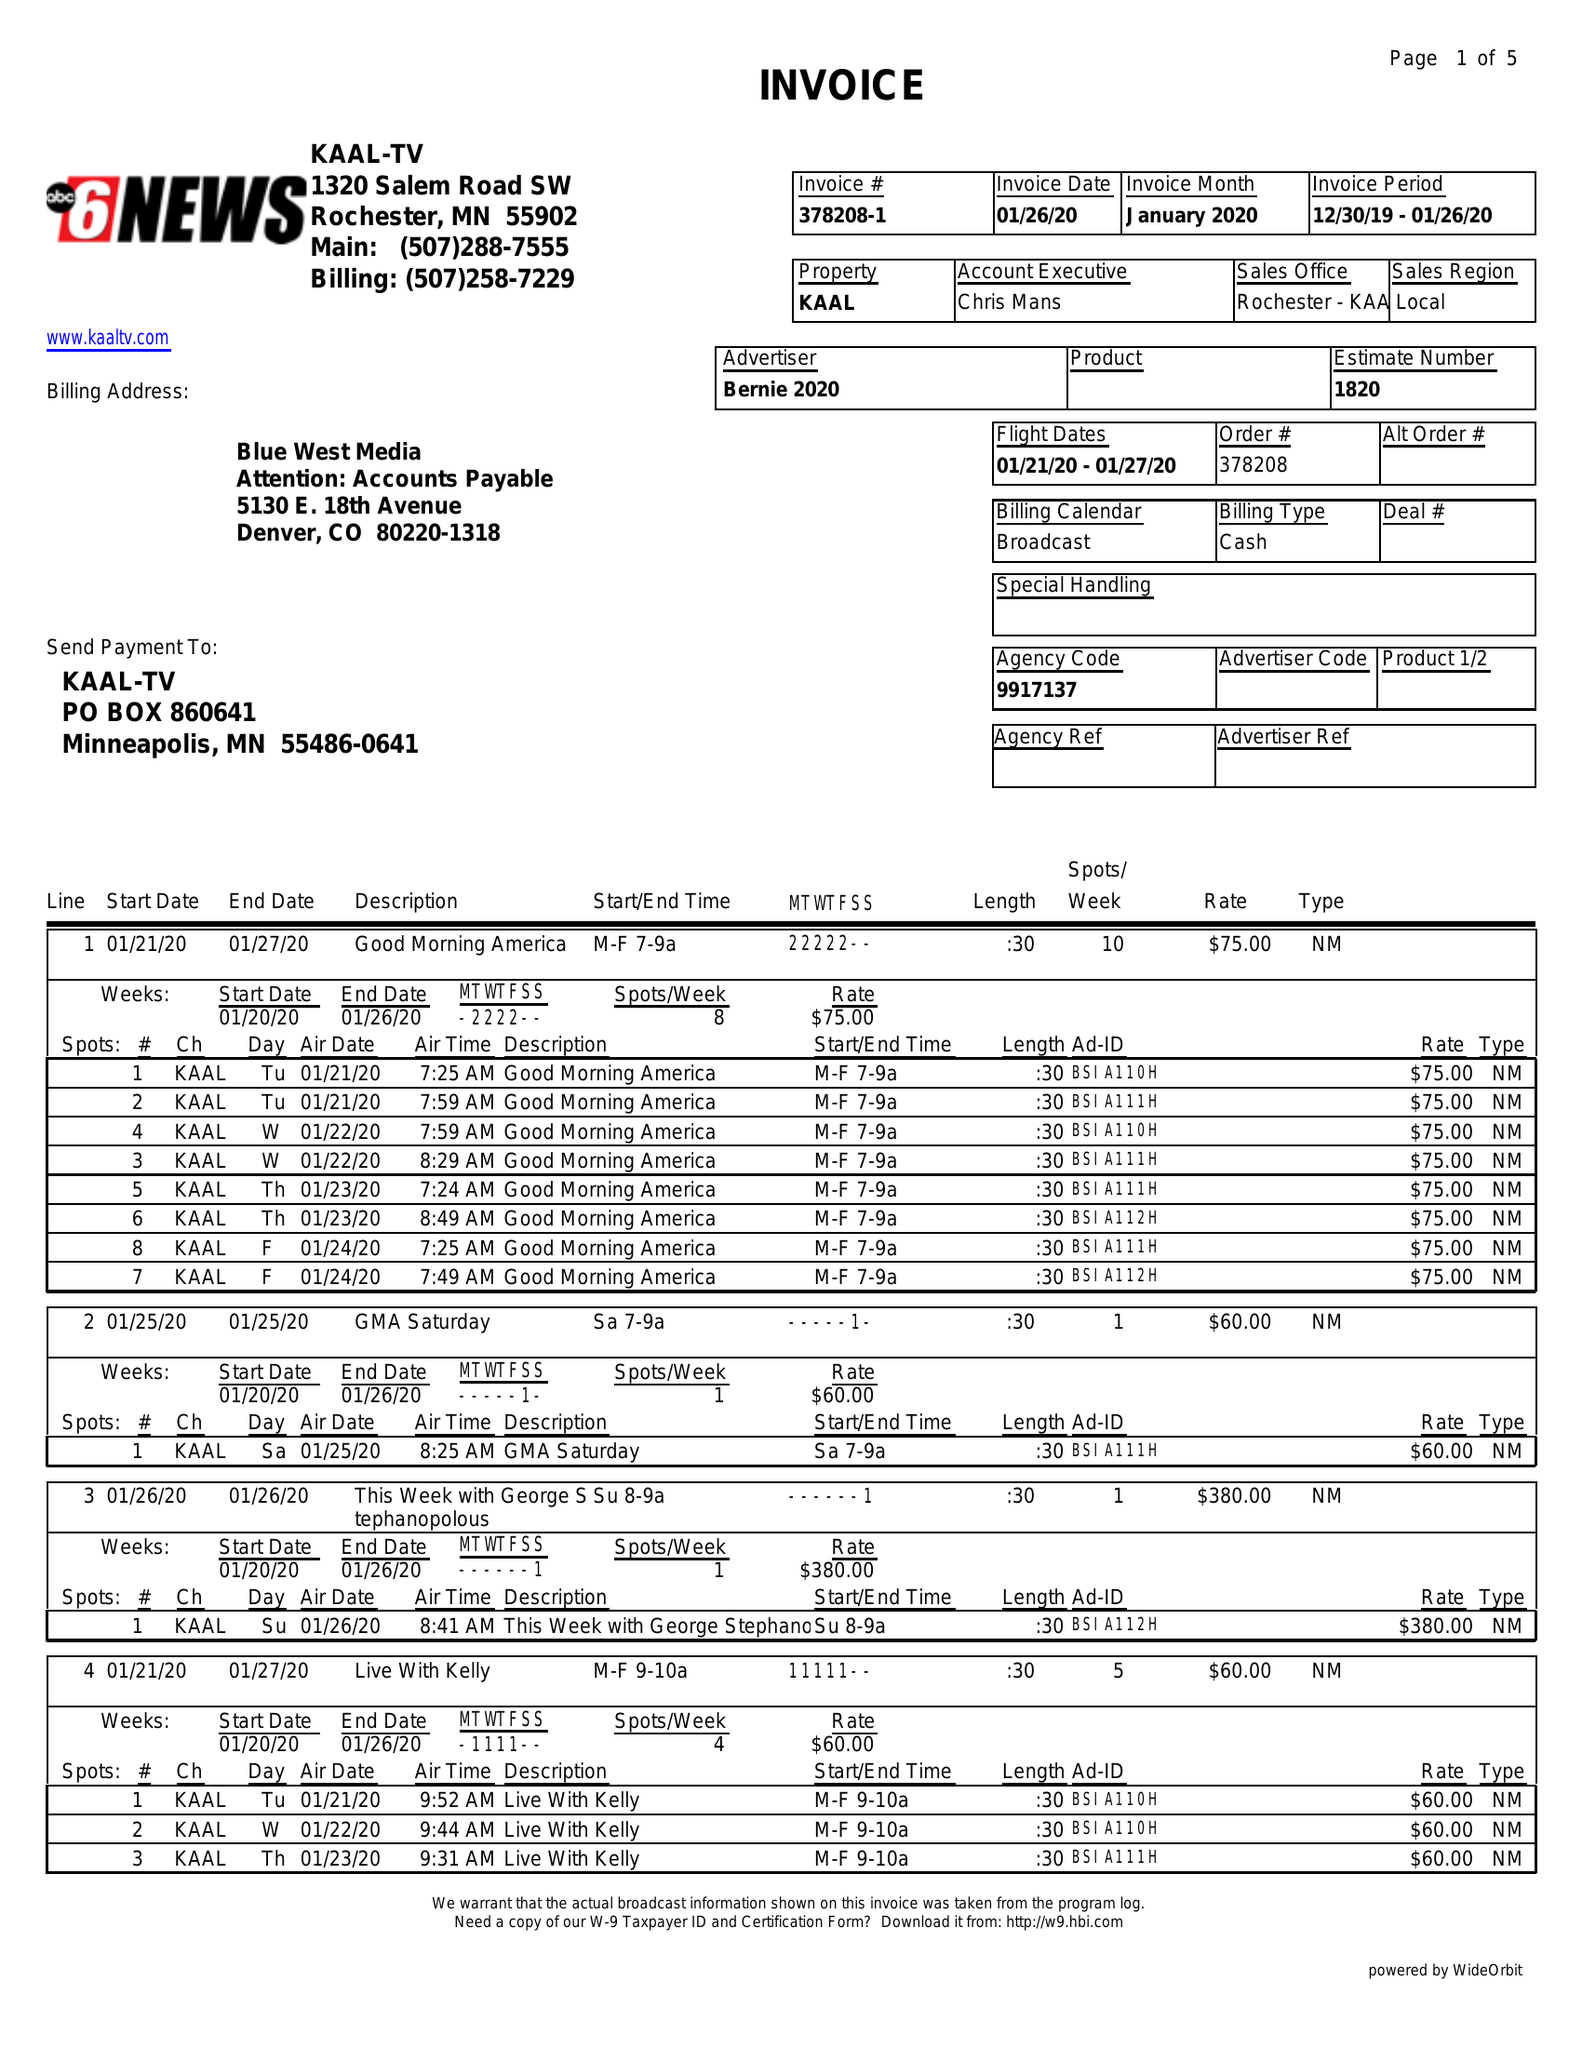What is the value for the flight_from?
Answer the question using a single word or phrase. 01/21/20 